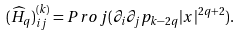<formula> <loc_0><loc_0><loc_500><loc_500>( \widehat { H } _ { q } ) _ { i j } ^ { ( k ) } = P r o j ( \partial _ { i } \partial _ { j } p _ { k - 2 q } | x | ^ { 2 q + 2 } ) .</formula> 